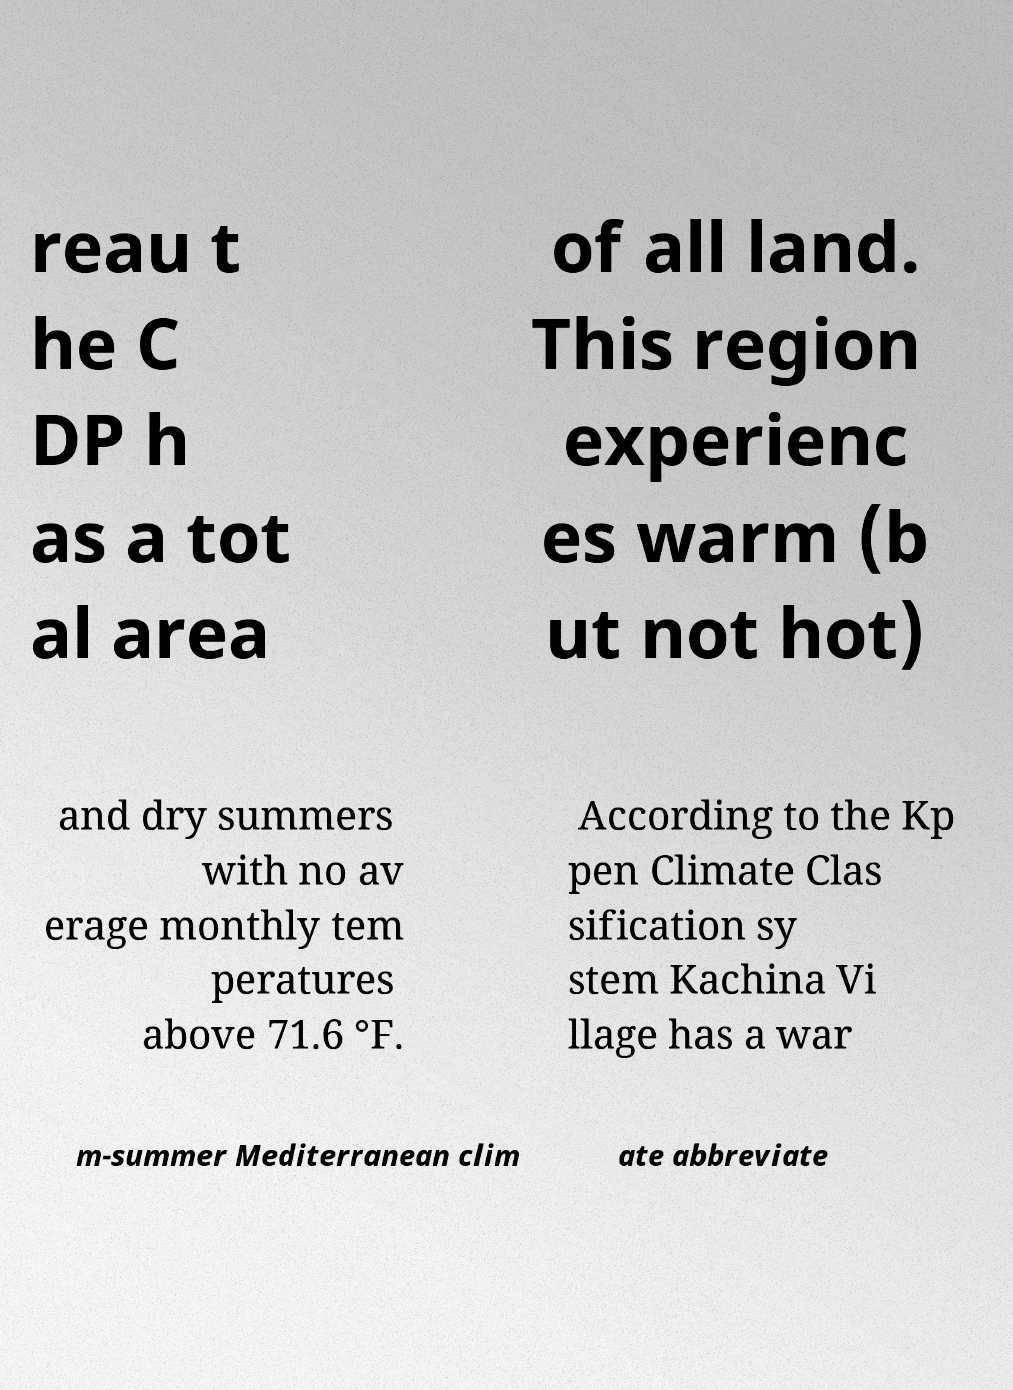Please read and relay the text visible in this image. What does it say? reau t he C DP h as a tot al area of all land. This region experienc es warm (b ut not hot) and dry summers with no av erage monthly tem peratures above 71.6 °F. According to the Kp pen Climate Clas sification sy stem Kachina Vi llage has a war m-summer Mediterranean clim ate abbreviate 